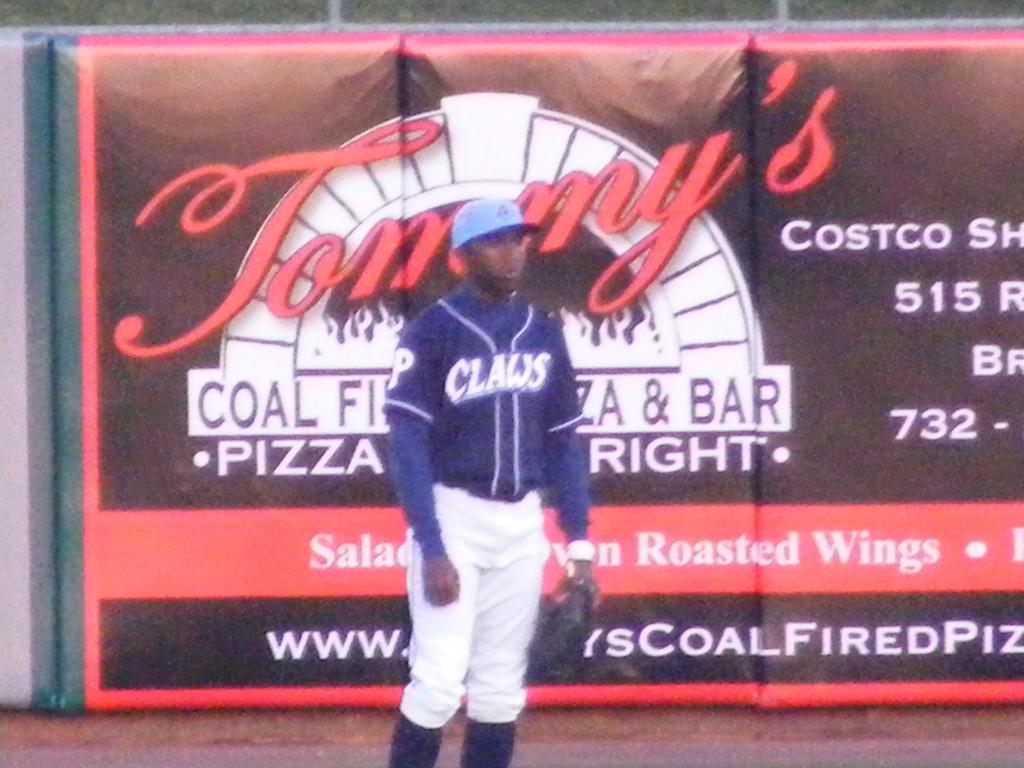What restaurant is the player standing in front of?
Your answer should be very brief. Tommy's. Who does he play for?
Keep it short and to the point. Claws. 